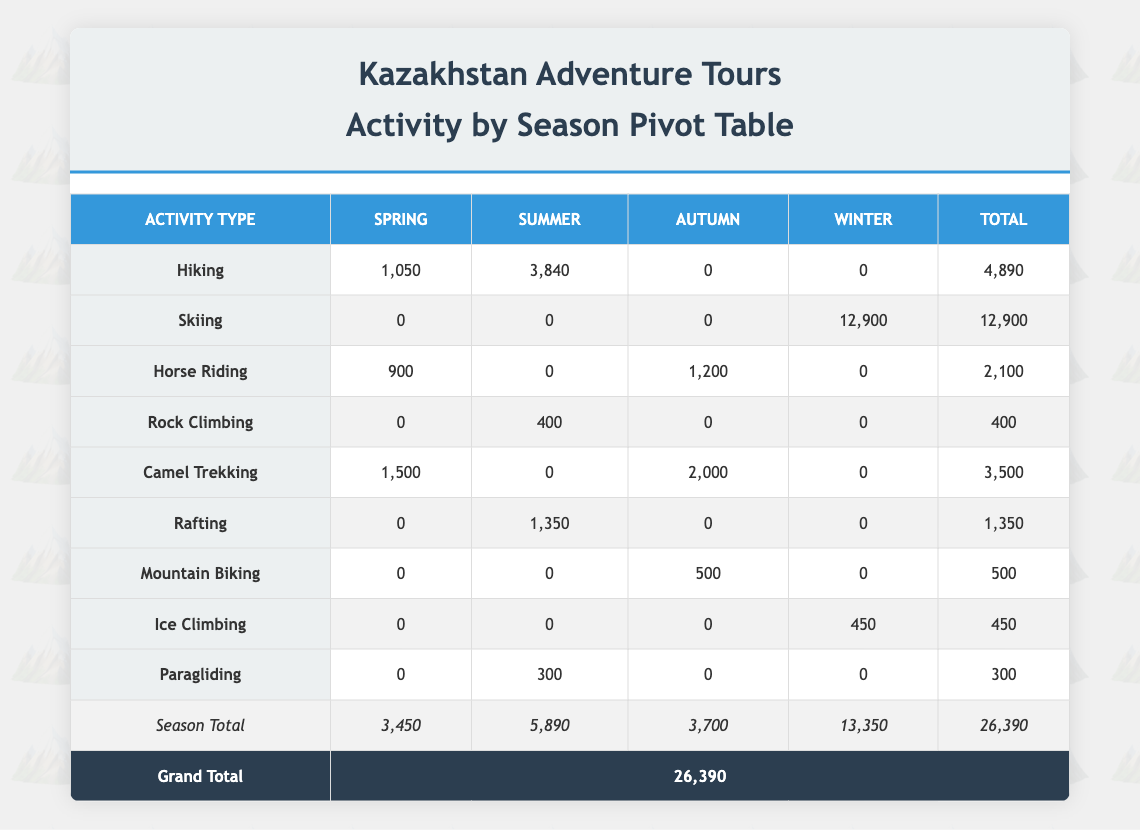What is the total revenue generated from Hiking in the Summer? The total revenue for Hiking in the Summer can be found in the "Summer" column under the "Hiking" row, which shows a value of 3840.
Answer: 3840 How much revenue was generated from Skiing activities? To find the revenue from Skiing, we look at the "Skiing" row. The total revenue is given in the last column, which is 12900.
Answer: 12900 Is the revenue from Horse Riding in the Spring more than in Autumn? The revenue for Horse Riding in Spring is 900, while in Autumn it is 1200. Since 900 is less than 1200, the statement is false.
Answer: No What is the difference in total revenue between Summer and Autumn? The total revenue for Summer is 5890 (sum of all Summer values), and for Autumn, it is 3700. The difference is 5890 - 3700 = 2190.
Answer: 2190 Which activity generated the least revenue overall? To determine this, we must compare the total revenues of each activity. The "Mountain Biking" activity has a total revenue of 500, which is the lowest among all listed activities.
Answer: Mountain Biking What is the average revenue for Camel Trekking across Spring and Autumn? The revenue for Camel Trekking in Spring is 1500 and in Autumn is 2000. We sum these values (1500 + 2000 = 3500) and divide by 2 (the number of seasons) to find the average: 3500 / 2 = 1750.
Answer: 1750 Is there any activity that generated revenue in every season? Upon examining the table, Skiing is the only activity that generates revenue exclusively during the Winter season, while other activities have revenues in selected seasons, confirming that no activity generates revenue in all seasons.
Answer: No What is the total revenue generated during Winter activities? The total revenue generated during Winter is calculated by adding the revenues from all Winter activities: Skiing (12900) + Ice Climbing (450) = 13350.
Answer: 13350 What is the highest revenue generated in a single booking, and for which activity? To find this, we check all activity revenues from each booking. The highest amount from the listings is for Skiing at Ak Bulak, which generated 6300 in a single booking.
Answer: 6300, Skiing 